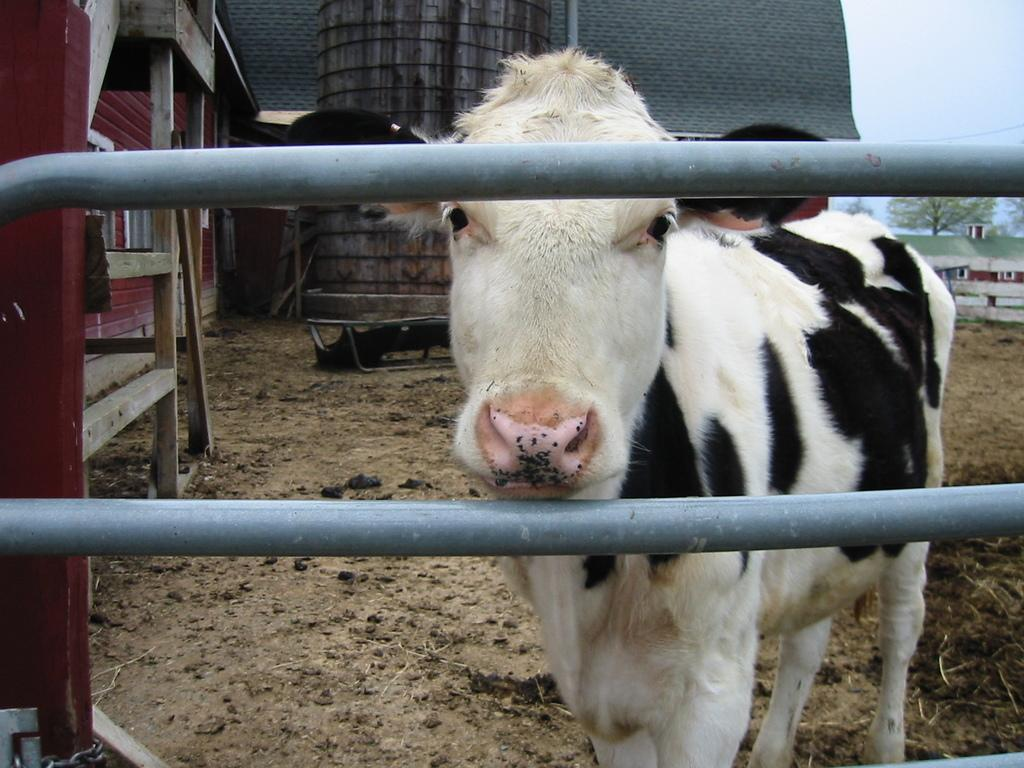What animal is standing in the image? There is a cow standing in the image. What type of structure can be seen in the image? There are iron grilles in the image. What type of buildings are present in the image? There are houses in the image. What type of vegetation is present in the image? There are trees in the image. What is visible behind the trees in the image? The sky is visible behind the trees in the image. How many brothers are depicted in the image? There is no reference to any brothers in the image; it features a cow, iron grilles, houses, trees, and the sky. 